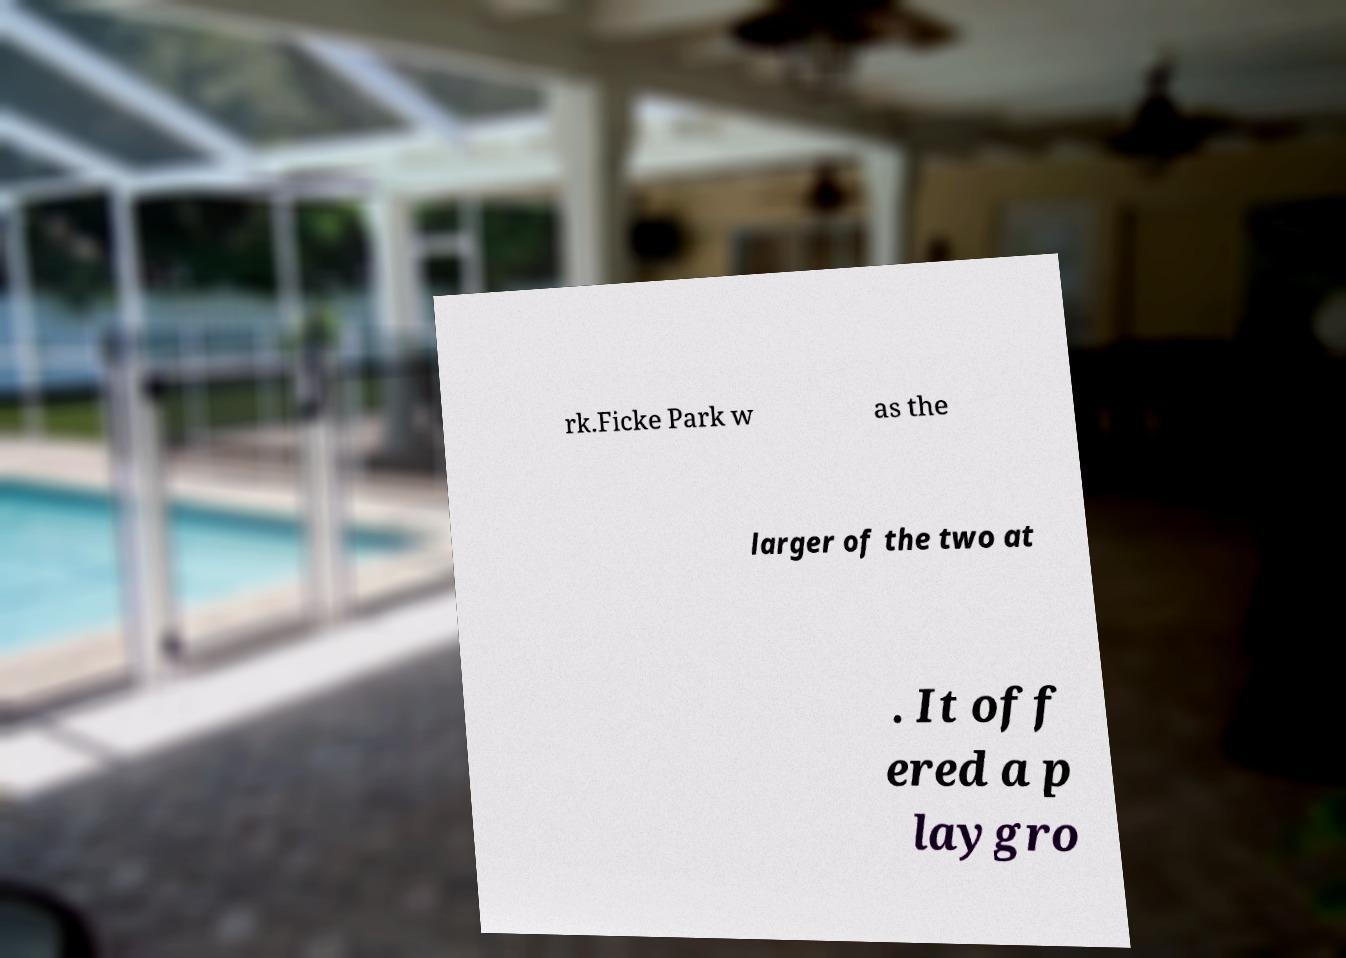I need the written content from this picture converted into text. Can you do that? rk.Ficke Park w as the larger of the two at . It off ered a p laygro 